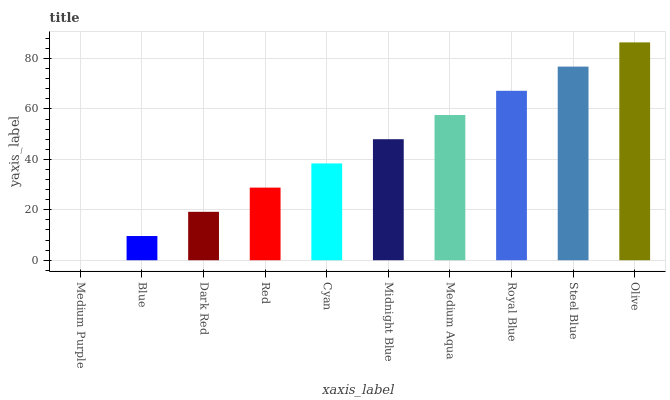Is Medium Purple the minimum?
Answer yes or no. Yes. Is Olive the maximum?
Answer yes or no. Yes. Is Blue the minimum?
Answer yes or no. No. Is Blue the maximum?
Answer yes or no. No. Is Blue greater than Medium Purple?
Answer yes or no. Yes. Is Medium Purple less than Blue?
Answer yes or no. Yes. Is Medium Purple greater than Blue?
Answer yes or no. No. Is Blue less than Medium Purple?
Answer yes or no. No. Is Midnight Blue the high median?
Answer yes or no. Yes. Is Cyan the low median?
Answer yes or no. Yes. Is Medium Aqua the high median?
Answer yes or no. No. Is Dark Red the low median?
Answer yes or no. No. 